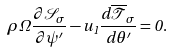Convert formula to latex. <formula><loc_0><loc_0><loc_500><loc_500>\rho \Omega \frac { \partial \mathcal { S } _ { \sigma } } { \partial \psi ^ { \prime } } - u _ { 1 } \frac { d \overline { \mathcal { T } } _ { \sigma } } { d \theta ^ { \prime } } = 0 .</formula> 